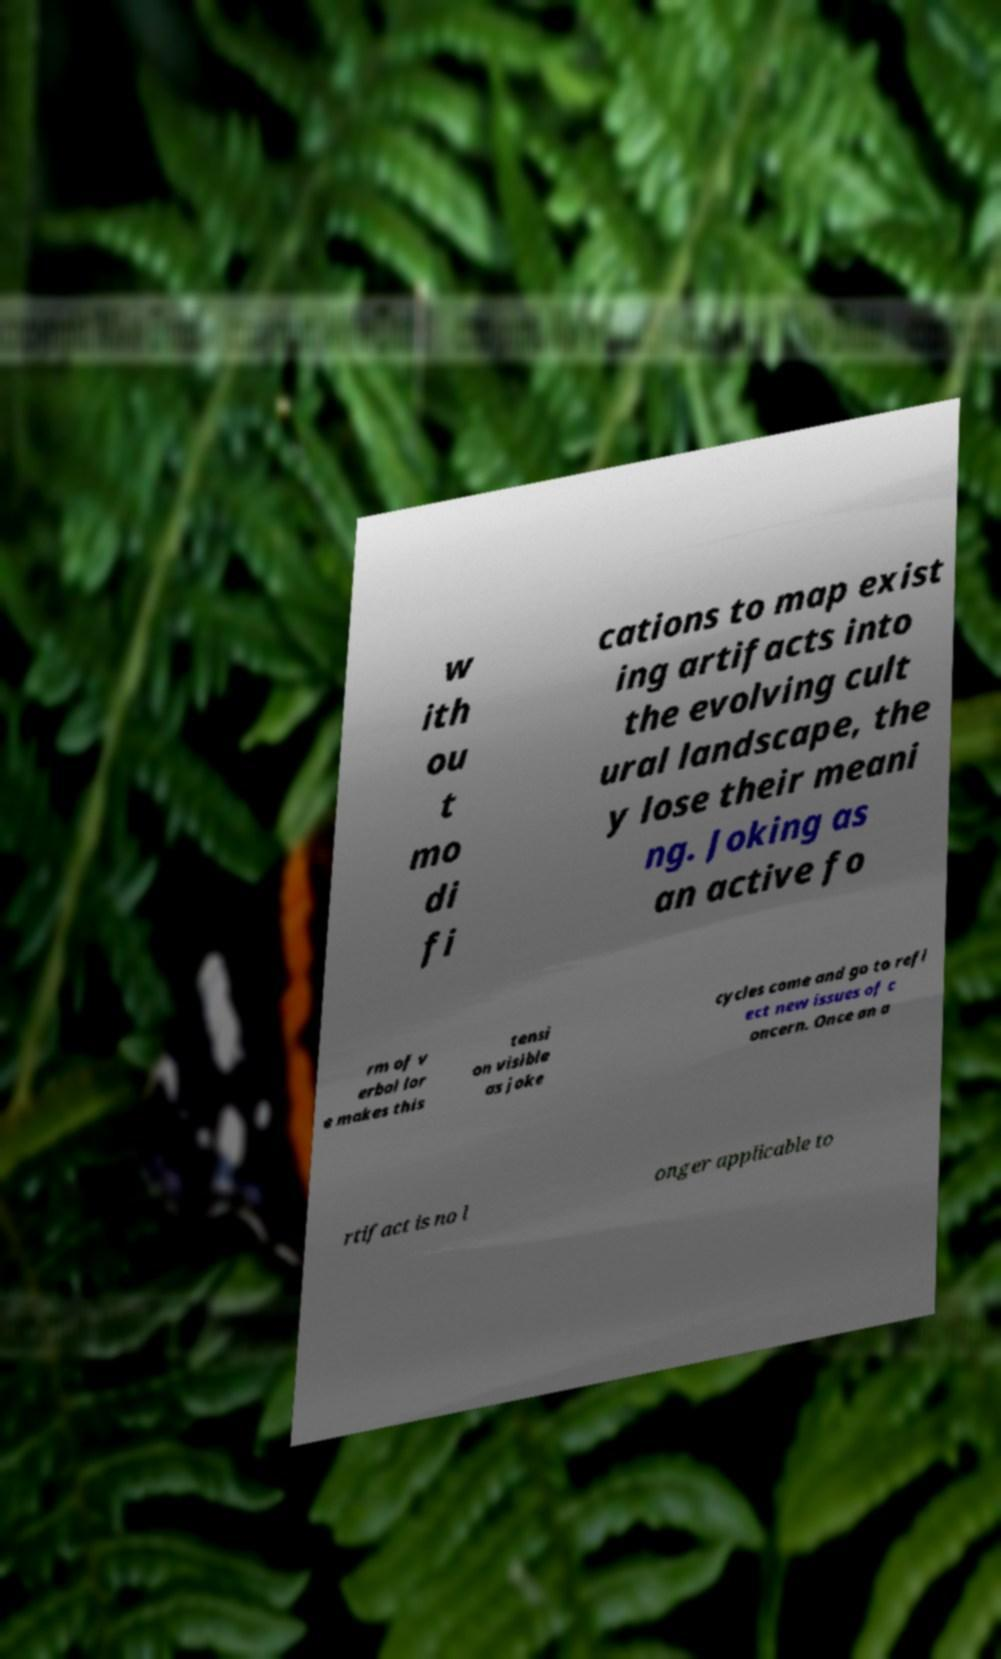There's text embedded in this image that I need extracted. Can you transcribe it verbatim? w ith ou t mo di fi cations to map exist ing artifacts into the evolving cult ural landscape, the y lose their meani ng. Joking as an active fo rm of v erbal lor e makes this tensi on visible as joke cycles come and go to refl ect new issues of c oncern. Once an a rtifact is no l onger applicable to 